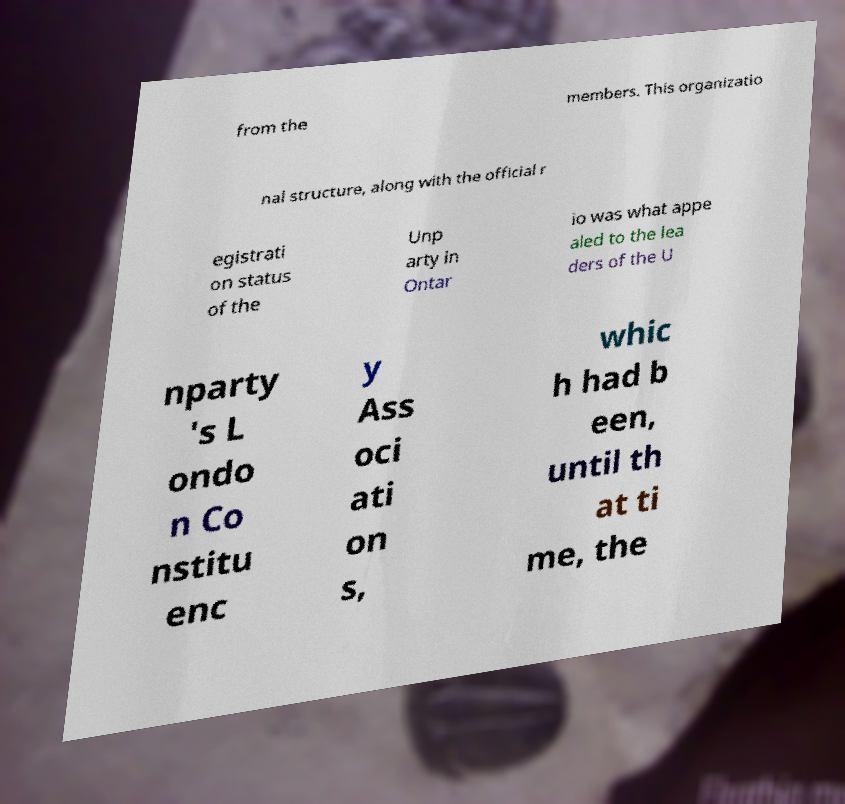Please identify and transcribe the text found in this image. from the members. This organizatio nal structure, along with the official r egistrati on status of the Unp arty in Ontar io was what appe aled to the lea ders of the U nparty 's L ondo n Co nstitu enc y Ass oci ati on s, whic h had b een, until th at ti me, the 